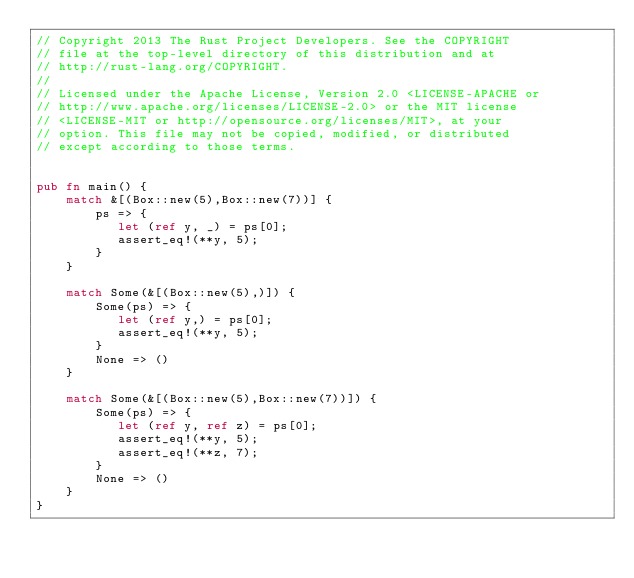Convert code to text. <code><loc_0><loc_0><loc_500><loc_500><_Rust_>// Copyright 2013 The Rust Project Developers. See the COPYRIGHT
// file at the top-level directory of this distribution and at
// http://rust-lang.org/COPYRIGHT.
//
// Licensed under the Apache License, Version 2.0 <LICENSE-APACHE or
// http://www.apache.org/licenses/LICENSE-2.0> or the MIT license
// <LICENSE-MIT or http://opensource.org/licenses/MIT>, at your
// option. This file may not be copied, modified, or distributed
// except according to those terms.


pub fn main() {
    match &[(Box::new(5),Box::new(7))] {
        ps => {
           let (ref y, _) = ps[0];
           assert_eq!(**y, 5);
        }
    }

    match Some(&[(Box::new(5),)]) {
        Some(ps) => {
           let (ref y,) = ps[0];
           assert_eq!(**y, 5);
        }
        None => ()
    }

    match Some(&[(Box::new(5),Box::new(7))]) {
        Some(ps) => {
           let (ref y, ref z) = ps[0];
           assert_eq!(**y, 5);
           assert_eq!(**z, 7);
        }
        None => ()
    }
}
</code> 